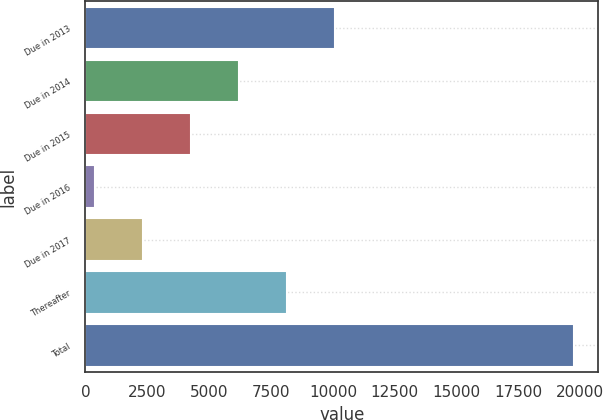Convert chart to OTSL. <chart><loc_0><loc_0><loc_500><loc_500><bar_chart><fcel>Due in 2013<fcel>Due in 2014<fcel>Due in 2015<fcel>Due in 2016<fcel>Due in 2017<fcel>Thereafter<fcel>Total<nl><fcel>10064.5<fcel>6198.7<fcel>4265.8<fcel>400<fcel>2332.9<fcel>8131.6<fcel>19729<nl></chart> 